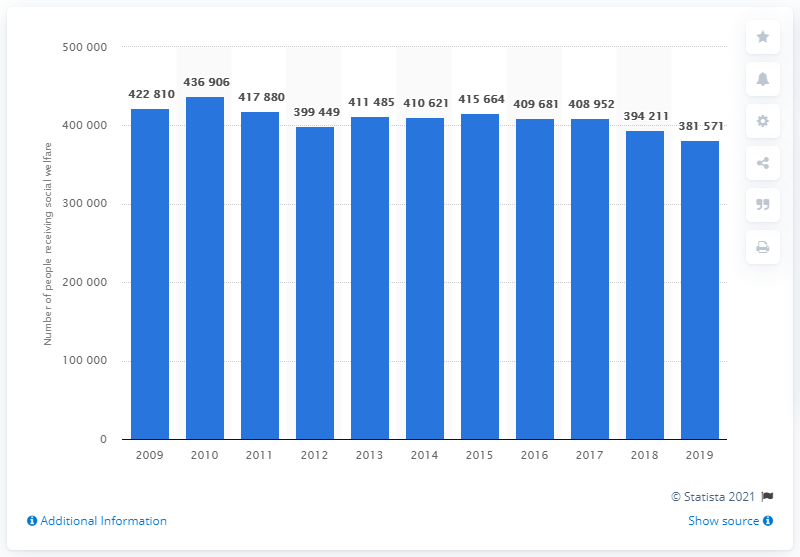Draw attention to some important aspects in this diagram. In 2019, a total of 381,571 individuals in Sweden received social welfare benefits. In 2010, a total of 436,906 individuals received social welfare benefits. 